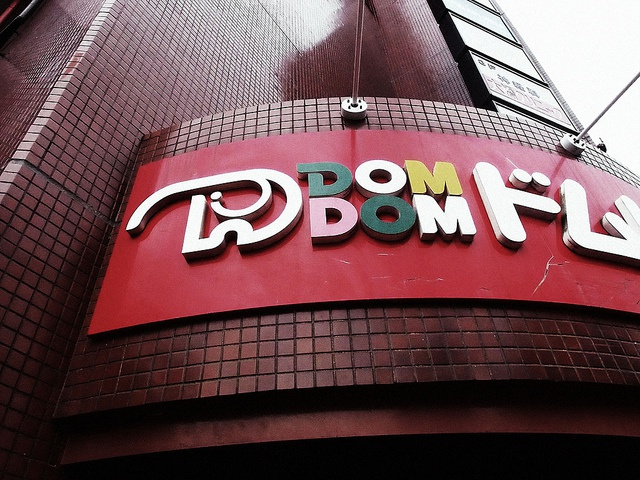Describe the objects in this image and their specific colors. I can see various objects in this image with different colors. 